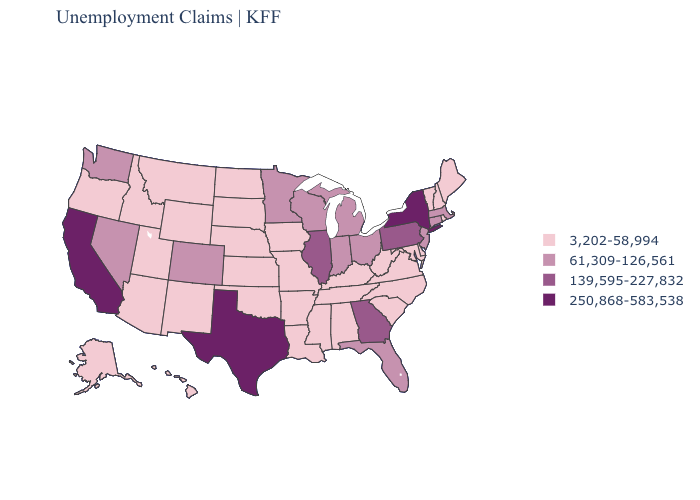What is the lowest value in states that border Kansas?
Write a very short answer. 3,202-58,994. Name the states that have a value in the range 139,595-227,832?
Be succinct. Georgia, Illinois, Pennsylvania. Name the states that have a value in the range 250,868-583,538?
Be succinct. California, New York, Texas. Which states hav the highest value in the South?
Short answer required. Texas. Is the legend a continuous bar?
Short answer required. No. Name the states that have a value in the range 61,309-126,561?
Concise answer only. Colorado, Connecticut, Florida, Indiana, Massachusetts, Michigan, Minnesota, Nevada, New Jersey, Ohio, Washington, Wisconsin. What is the value of New Mexico?
Concise answer only. 3,202-58,994. Name the states that have a value in the range 61,309-126,561?
Keep it brief. Colorado, Connecticut, Florida, Indiana, Massachusetts, Michigan, Minnesota, Nevada, New Jersey, Ohio, Washington, Wisconsin. Does Nebraska have a lower value than Connecticut?
Give a very brief answer. Yes. Does Maryland have the lowest value in the USA?
Write a very short answer. Yes. Name the states that have a value in the range 61,309-126,561?
Keep it brief. Colorado, Connecticut, Florida, Indiana, Massachusetts, Michigan, Minnesota, Nevada, New Jersey, Ohio, Washington, Wisconsin. Which states have the highest value in the USA?
Answer briefly. California, New York, Texas. Name the states that have a value in the range 139,595-227,832?
Give a very brief answer. Georgia, Illinois, Pennsylvania. Does California have the highest value in the USA?
Short answer required. Yes. Is the legend a continuous bar?
Quick response, please. No. 